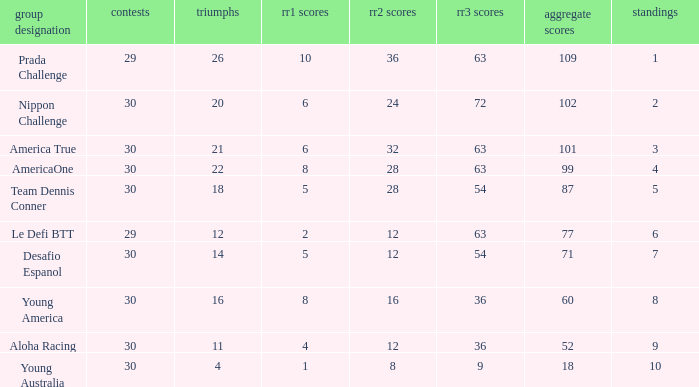Name the min total pts for team dennis conner 87.0. 